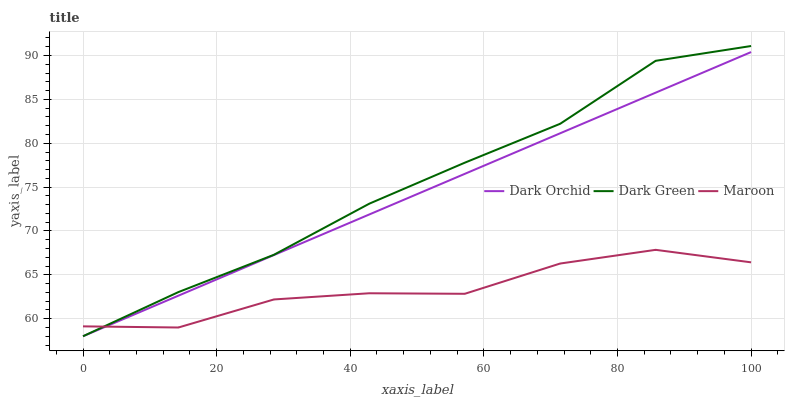Does Maroon have the minimum area under the curve?
Answer yes or no. Yes. Does Dark Green have the maximum area under the curve?
Answer yes or no. Yes. Does Dark Orchid have the minimum area under the curve?
Answer yes or no. No. Does Dark Orchid have the maximum area under the curve?
Answer yes or no. No. Is Dark Orchid the smoothest?
Answer yes or no. Yes. Is Maroon the roughest?
Answer yes or no. Yes. Is Dark Green the smoothest?
Answer yes or no. No. Is Dark Green the roughest?
Answer yes or no. No. Does Dark Orchid have the highest value?
Answer yes or no. No. 